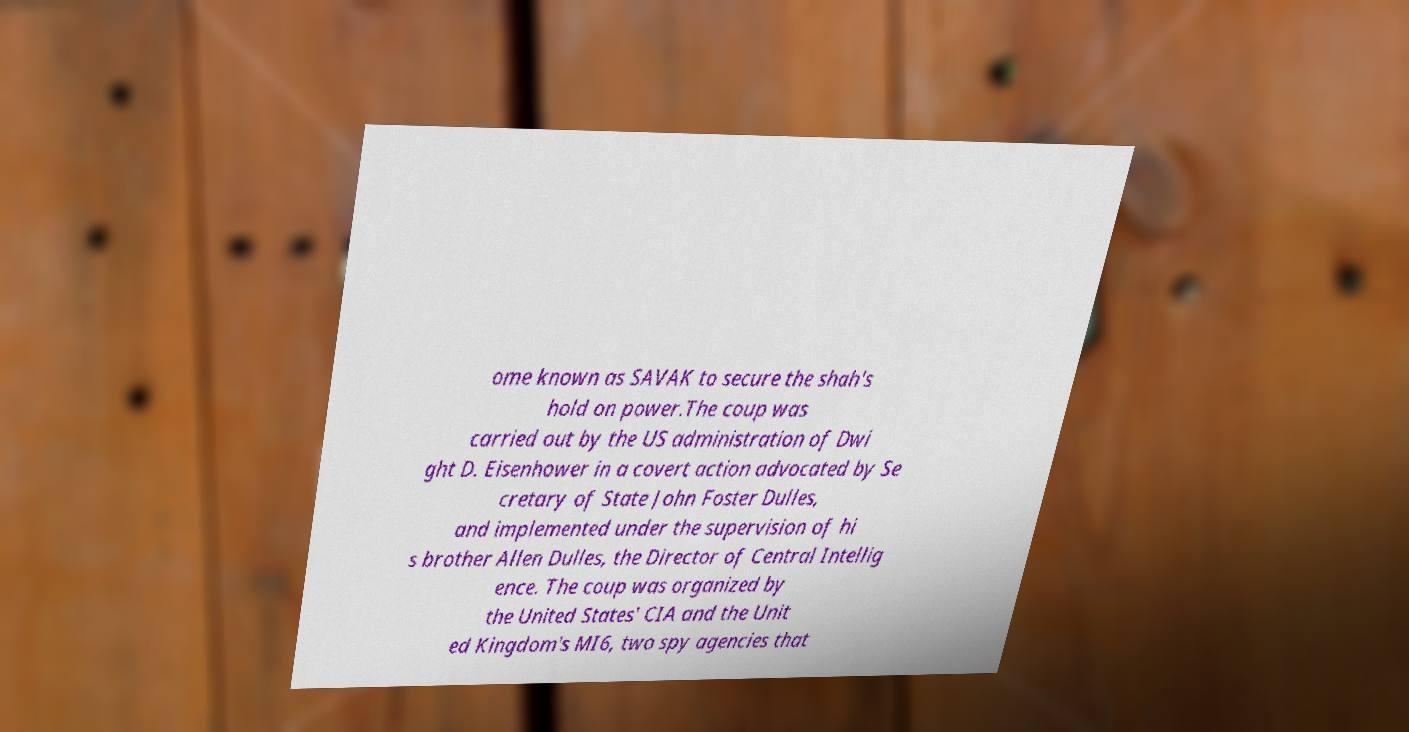Could you assist in decoding the text presented in this image and type it out clearly? ome known as SAVAK to secure the shah's hold on power.The coup was carried out by the US administration of Dwi ght D. Eisenhower in a covert action advocated by Se cretary of State John Foster Dulles, and implemented under the supervision of hi s brother Allen Dulles, the Director of Central Intellig ence. The coup was organized by the United States' CIA and the Unit ed Kingdom's MI6, two spy agencies that 